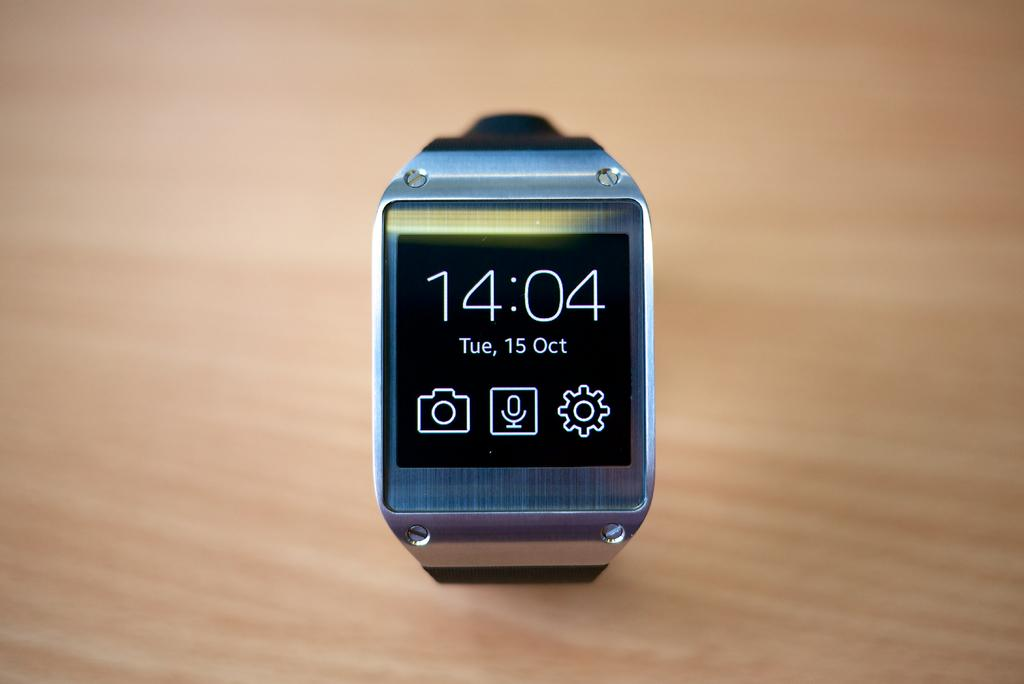<image>
Relay a brief, clear account of the picture shown. A GRAY COLORED SMART WATCH WITH THE TIME 14:04 